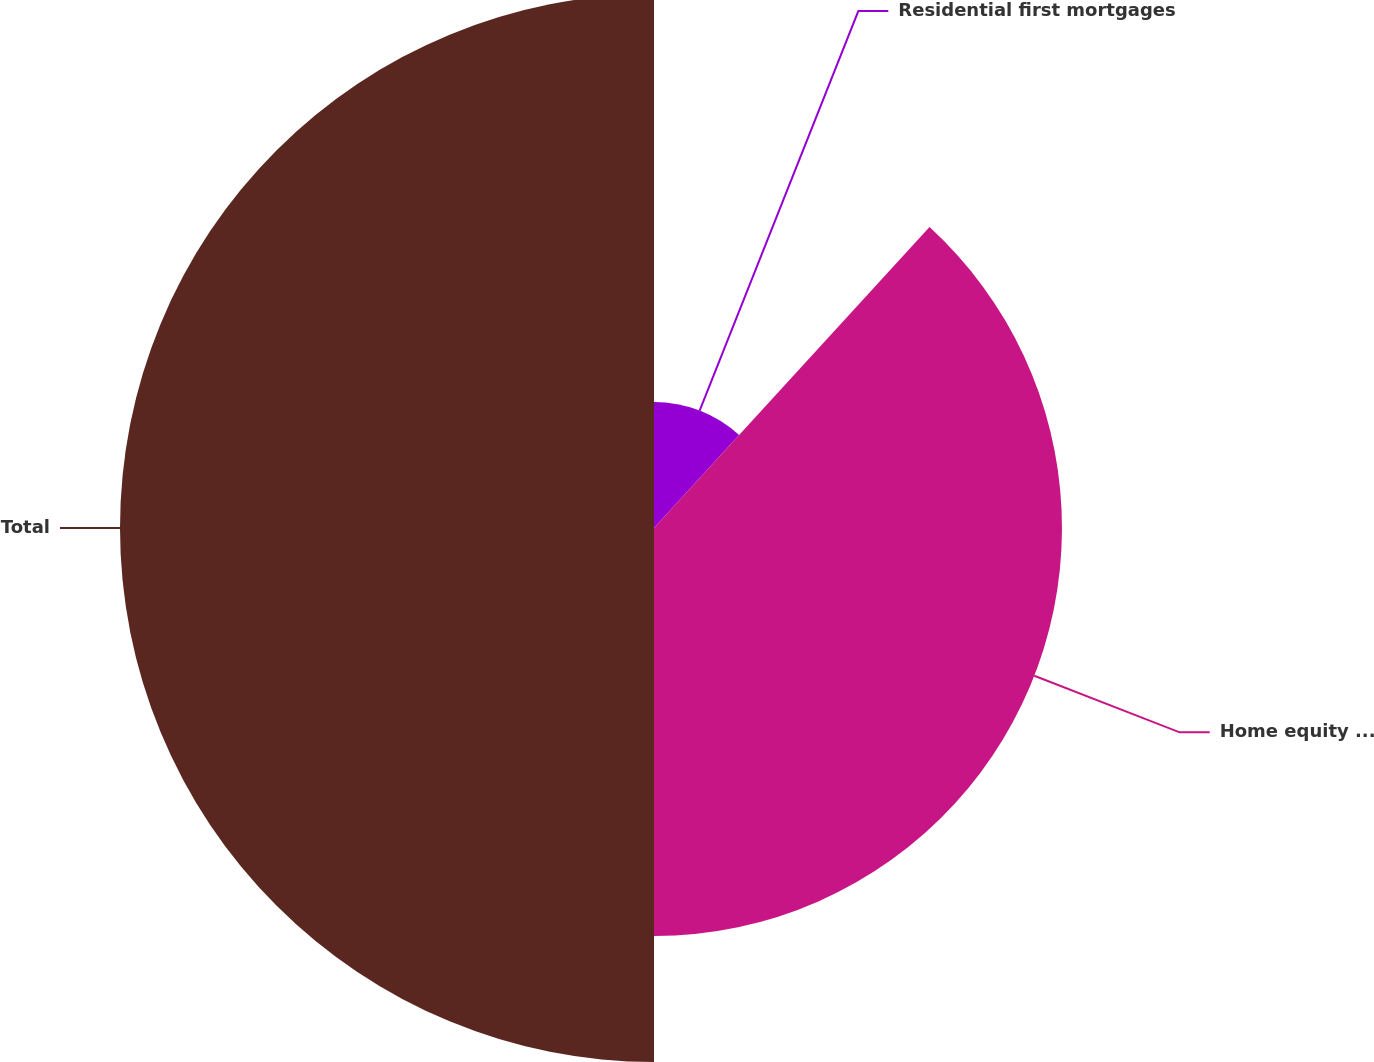<chart> <loc_0><loc_0><loc_500><loc_500><pie_chart><fcel>Residential first mortgages<fcel>Home equity loans<fcel>Total<nl><fcel>11.8%<fcel>38.2%<fcel>50.0%<nl></chart> 